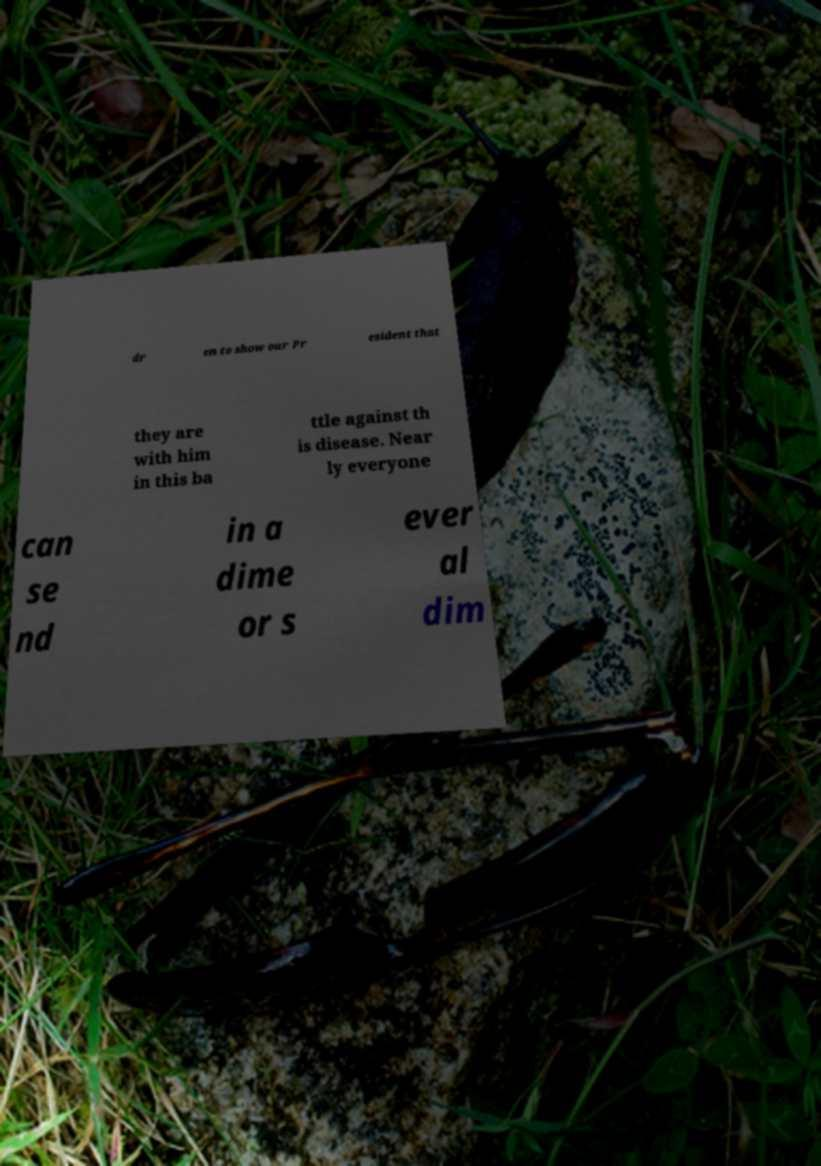I need the written content from this picture converted into text. Can you do that? dr en to show our Pr esident that they are with him in this ba ttle against th is disease. Near ly everyone can se nd in a dime or s ever al dim 